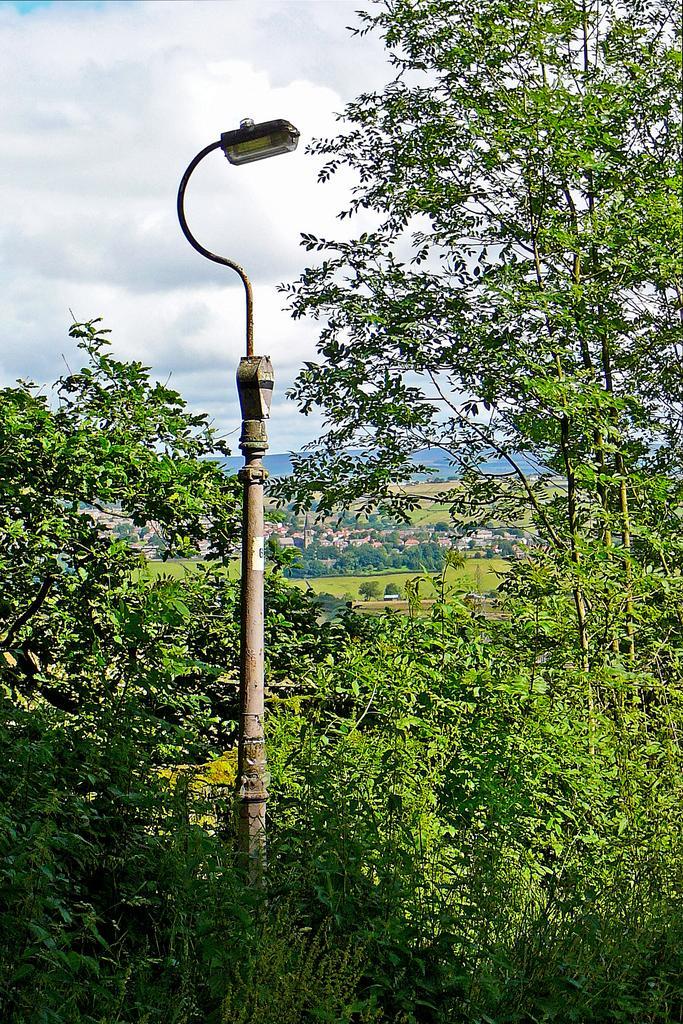In one or two sentences, can you explain what this image depicts? In this image, at the left side there is a pole, on that pole there is a light, we can see some green color plants and trees, at the top there is a sky which is cloudy. 